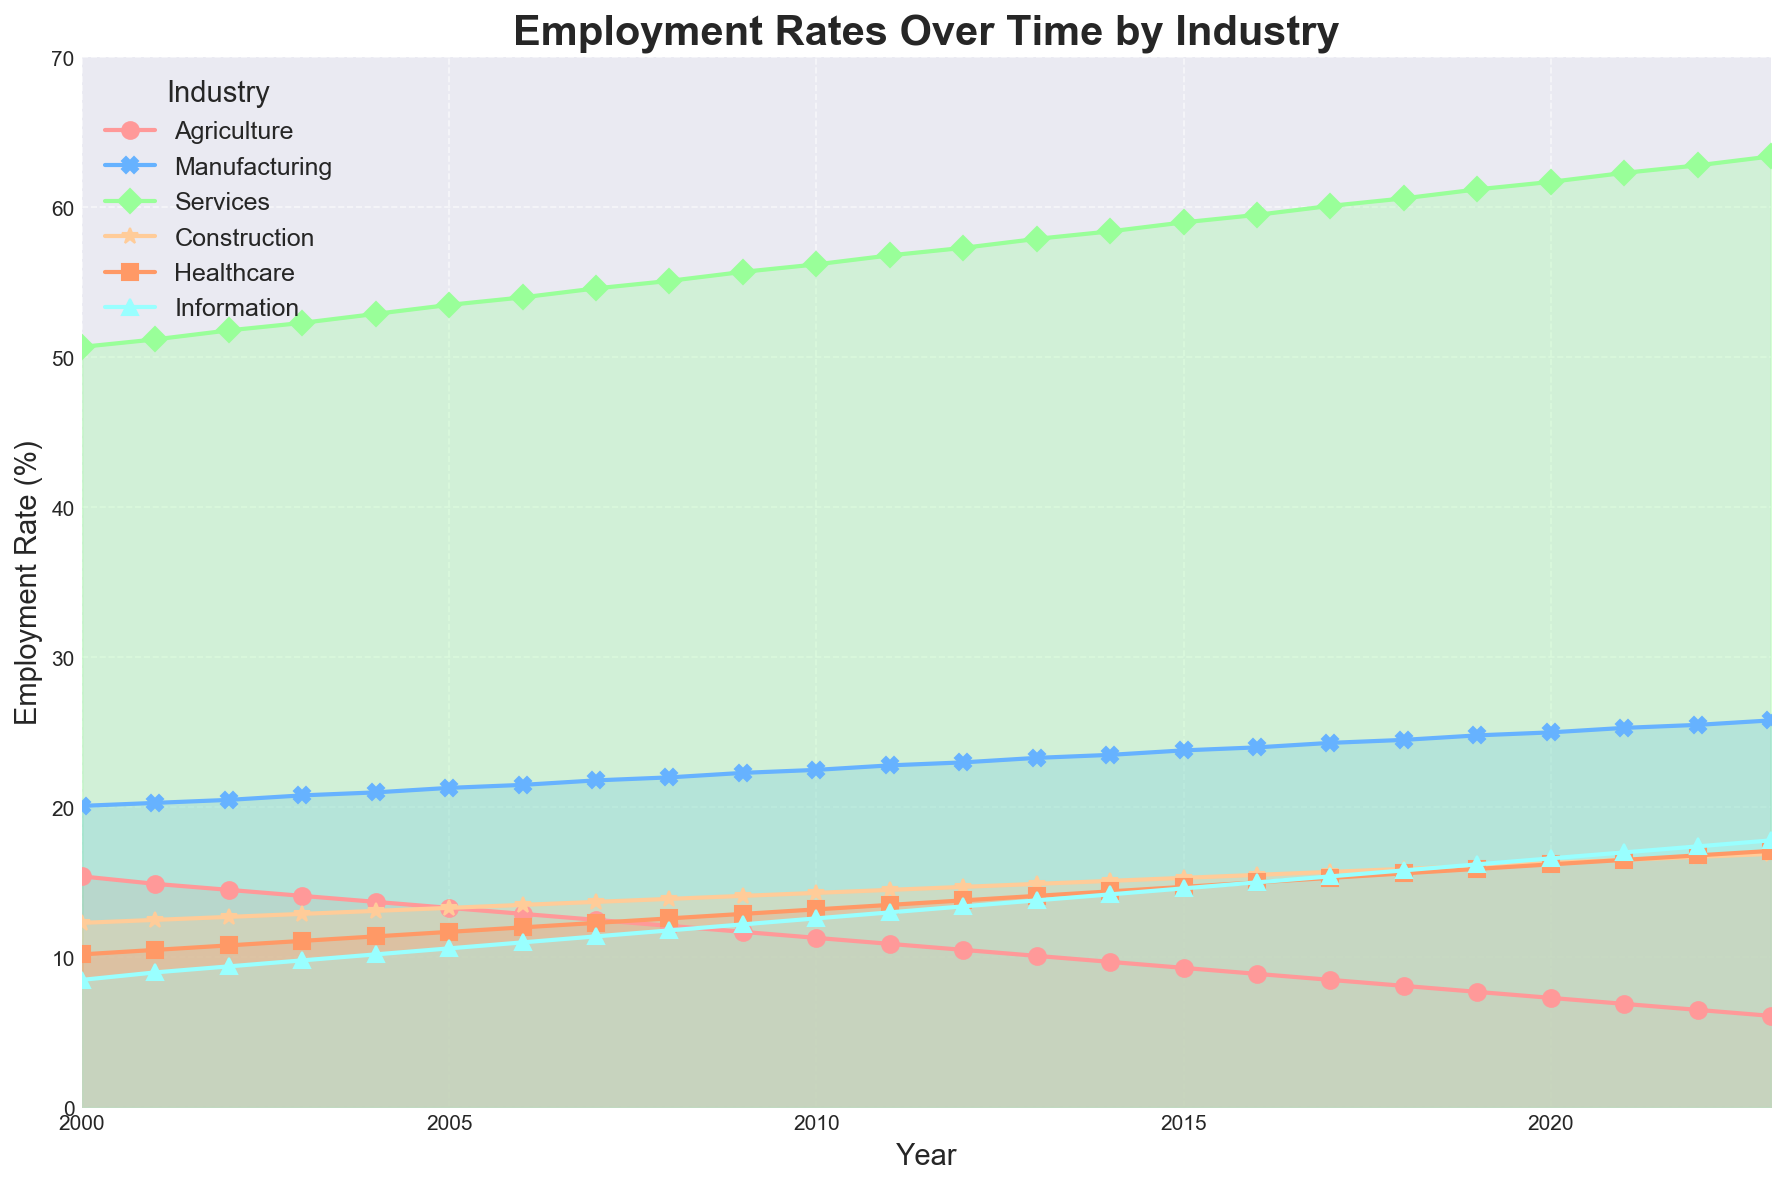What industry had the lowest employment rate in 2000? Looking at the figure, the industry with the line closest to the bottom in 2000 is Agriculture.
Answer: Agriculture Which industry shows the most consistent increase in employment rate over the years? Observing the steepness and consistency of the lines, Services shows a regular upward trend from 2000 to 2023.
Answer: Services What is the difference in employment rates between Healthcare and Agriculture in 2023? In 2023, the employment rate for Healthcare is around 17.1%, and for Agriculture, it is about 6.1%. The difference is 17.1 - 6.1 = 11.0%.
Answer: 11.0% In which year did the Information industry surpass a 10% employment rate? The Information industry line surpasses the 10% mark between 2005 and 2006.
Answer: 2006 Between Manufacturing and Construction, which industry had a higher employment rate in 2010? Checking the height of the lines in 2010, Manufacturing is around 22.5% while Construction is at about 14.3%.
Answer: Manufacturing How much did the employment rate for Services increase from 2000 to 2023? The employment rate for Services in 2000 was approximately 50.7%, and in 2023 it was about 63.4%. The increase is 63.4 - 50.7 = 12.7%.
Answer: 12.7% What is the average employment rate for Construction from 2015 to 2020? Adding the employment rates for Construction from 2015 to 2020 (15.3 + 15.5 + 15.7 + 15.9 + 16.1 + 16.3) and dividing by the number of years (6), (15.3 + 15.5 + 15.7 + 15.9 + 16.1 + 16.3) / 6 = 15.8%.
Answer: 15.8% Which industry had the second highest employment rate in 2022? By checking the relative height of the lines in 2022, the industry with the second highest rate is Services, with an employment rate just below Healthcare.
Answer: Services 